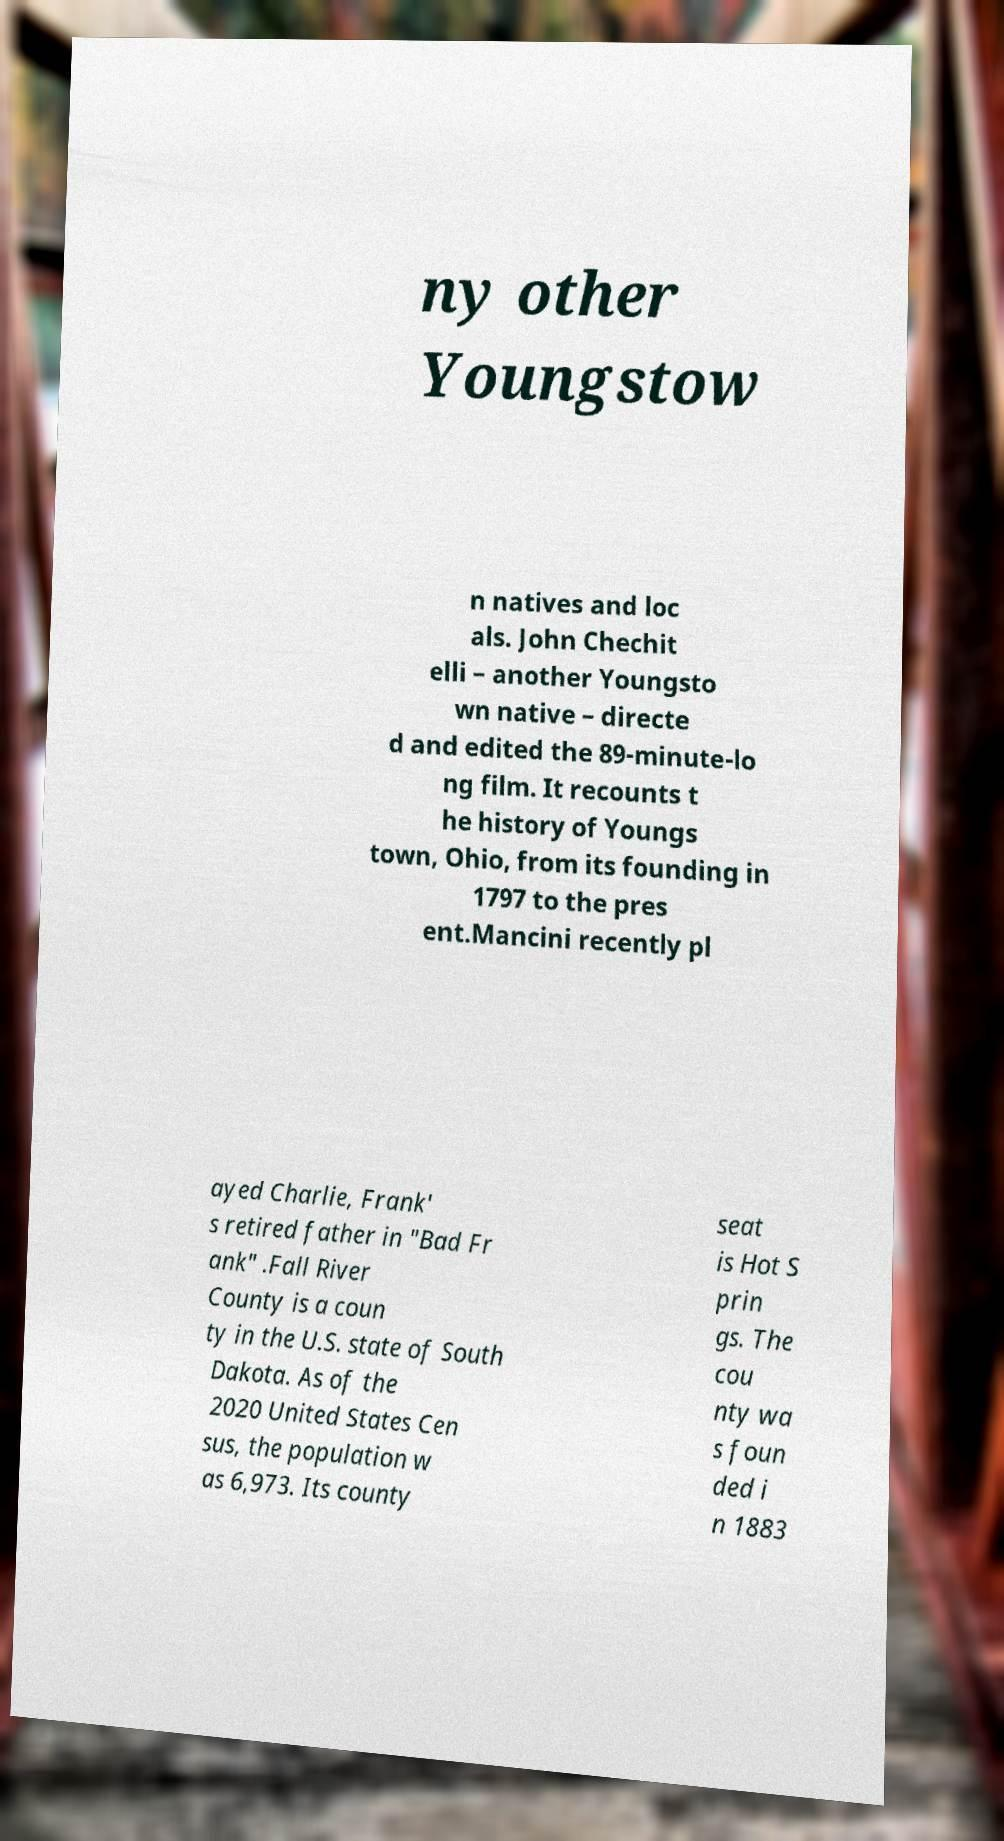Please read and relay the text visible in this image. What does it say? ny other Youngstow n natives and loc als. John Chechit elli – another Youngsto wn native – directe d and edited the 89-minute-lo ng film. It recounts t he history of Youngs town, Ohio, from its founding in 1797 to the pres ent.Mancini recently pl ayed Charlie, Frank' s retired father in "Bad Fr ank" .Fall River County is a coun ty in the U.S. state of South Dakota. As of the 2020 United States Cen sus, the population w as 6,973. Its county seat is Hot S prin gs. The cou nty wa s foun ded i n 1883 